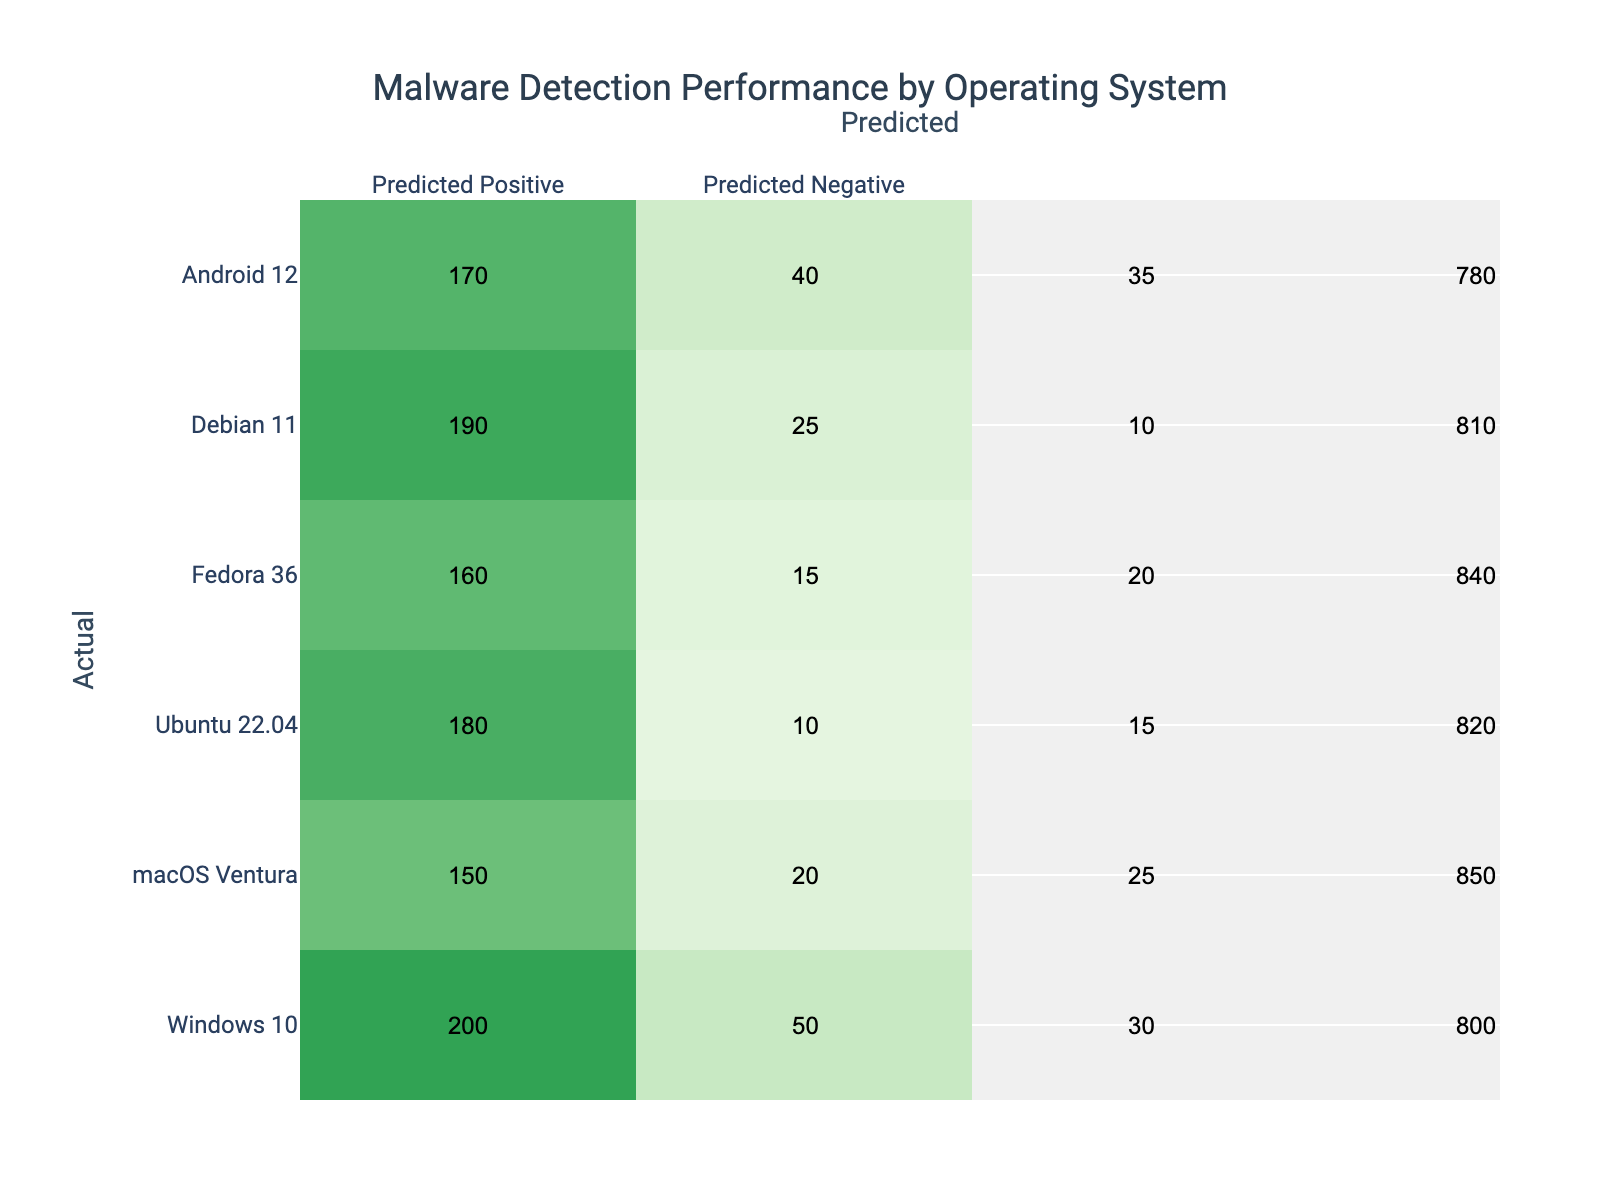What is the True Positive rate for Windows 10? The True Positive rate can be calculated using the formula: True Positive Rate = True Positive / (True Positive + False Negative). For Windows 10, True Positive is 200 and False Negative is 30. So, the True Positive rate is 200 / (200 + 30) = 200 / 230 ≈ 0.869, or approximately 87%.
Answer: 87% What is the False Positive rate for Ubuntu 22.04? The False Positive rate can be calculated using the formula: False Positive Rate = False Positive / (False Positive + True Negative). For Ubuntu 22.04, False Positive is 10 and True Negative is 820. So, the False Positive rate is 10 / (10 + 820) = 10 / 830 ≈ 0.012, or approximately 1.2%.
Answer: 1.2% Is the True Negative count highest for macOS Ventura? Yes, the True Negative for macOS Ventura is 850, which is higher compared to other operating systems in the table. The next closest is Ubuntu 22.04 with 820 True Negatives, making macOS Ventura the highest.
Answer: Yes Which operating system has the highest combined True Positive and True Negative count? The combined True Positive and True Negative counts are calculated as: True Positive + True Negative. For each OS: Windows 10 = 200 + 800 = 1000, macOS Ventura = 150 + 850 = 1000, Ubuntu 22.04 = 180 + 820 = 1000, Fedora 36 = 160 + 840 = 1000, Debian 11 = 190 + 810 = 1000, and Android 12 = 170 + 780 = 950. All OS except Android 12 have a combined count of 1000.
Answer: All have the same count except Android 12 What is the average True Positive value across all operating systems? The average can be calculated by summing the True Positive values and dividing by the number of operating systems. Total True Positives = 200 + 150 + 180 + 160 + 190 + 170 = 1050. There are 6 operating systems, so the average is 1050 / 6 = 175.
Answer: 175 Is there a pattern in True Positives related to operating system type? Yes, analysis of the True Positive values shows that mobile OS (Android 12) generally display lower True Positive rates than desktop OS (like Windows and macOS) which have higher counts, suggesting desktop OS may have better malware detection performance.
Answer: Yes 